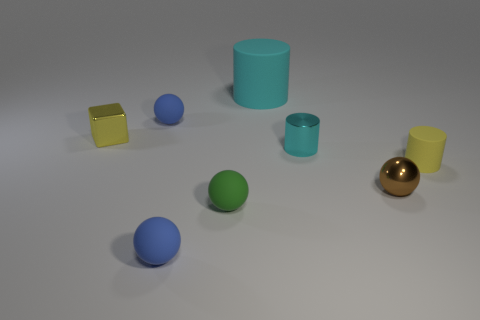What shape is the blue thing in front of the tiny green rubber ball to the left of the large cyan object?
Provide a succinct answer. Sphere. There is a metallic thing that is the same shape as the big rubber object; what is its color?
Offer a very short reply. Cyan. Do the thing in front of the green object and the large cyan matte thing have the same size?
Your response must be concise. No. What shape is the tiny object that is the same color as the small cube?
Provide a short and direct response. Cylinder. What number of small brown spheres are the same material as the small cyan cylinder?
Ensure brevity in your answer.  1. What is the material of the small blue object behind the thing that is on the left side of the blue rubber object that is behind the brown metal thing?
Offer a very short reply. Rubber. There is a small sphere behind the yellow object left of the large thing; what color is it?
Provide a short and direct response. Blue. The shiny sphere that is the same size as the yellow cylinder is what color?
Give a very brief answer. Brown. What number of tiny things are either brown metallic things or red objects?
Offer a very short reply. 1. Is the number of tiny brown metal things behind the big cylinder greater than the number of objects that are behind the tiny green rubber object?
Your answer should be compact. No. 